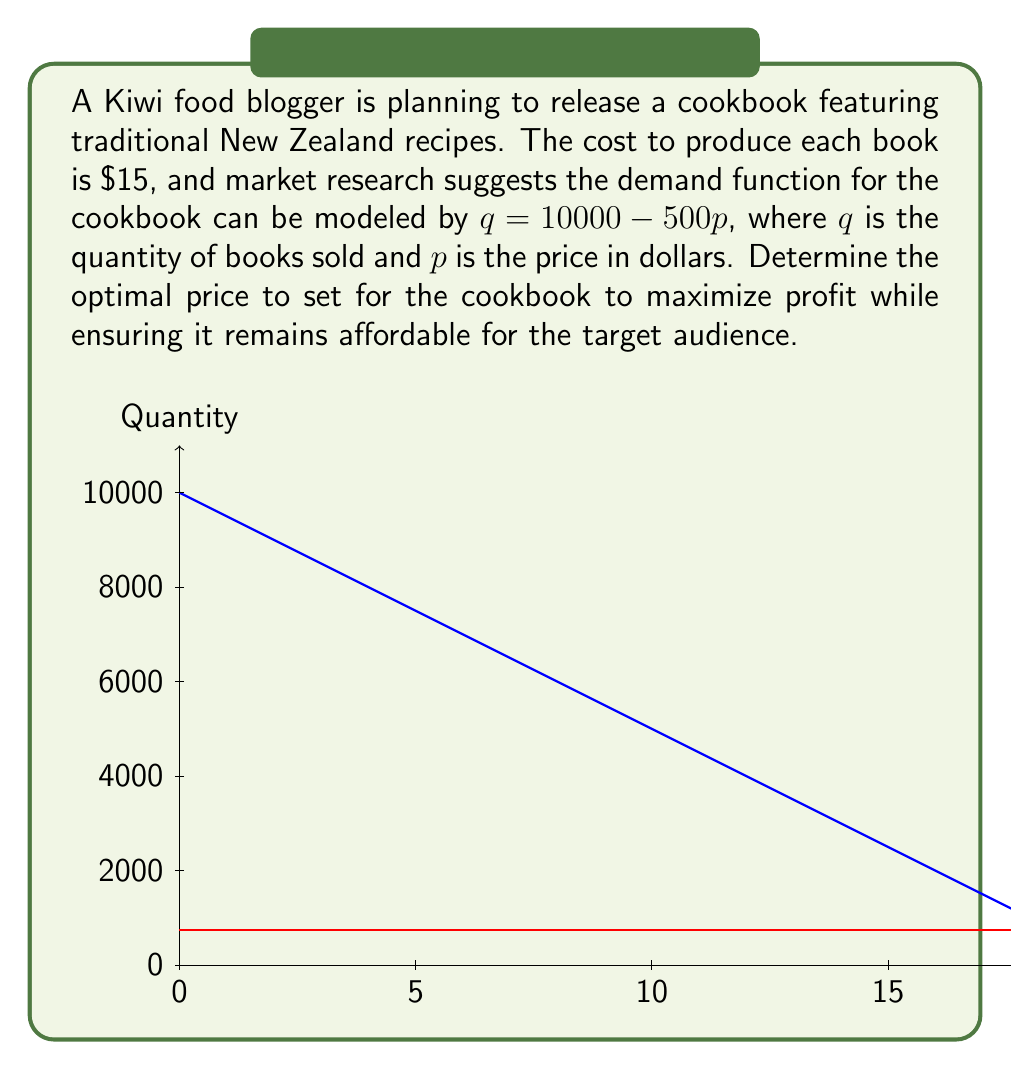Give your solution to this math problem. Let's approach this step-by-step:

1) The profit function is given by:
   $\pi = pq - 15q$, where $\pi$ is profit, $p$ is price, and $q$ is quantity.

2) Substitute the demand function $q = 10000 - 500p$ into the profit function:
   $\pi = p(10000 - 500p) - 15(10000 - 500p)$

3) Expand the equation:
   $\pi = 10000p - 500p^2 - 150000 + 7500p$

4) Simplify:
   $\pi = -500p^2 + 17500p - 150000$

5) To find the maximum profit, differentiate $\pi$ with respect to $p$ and set it to zero:
   $\frac{d\pi}{dp} = -1000p + 17500 = 0$

6) Solve for $p$:
   $1000p = 17500$
   $p = 17.50$

7) To confirm this is a maximum, check the second derivative:
   $\frac{d^2\pi}{dp^2} = -1000$, which is negative, confirming a maximum.

8) Calculate the quantity sold at this price:
   $q = 10000 - 500(17.50) = 1250$ cookbooks

9) Check if this price is affordable:
   $17.50 is a reasonable price for a cookbook, balancing profit and affordability.

10) Calculate the maximum profit:
    $\pi = 17.50(1250) - 15(1250) = 3125$

Therefore, the optimal price to maximize profit while keeping the cookbook affordable is $17.50.
Answer: $17.50 